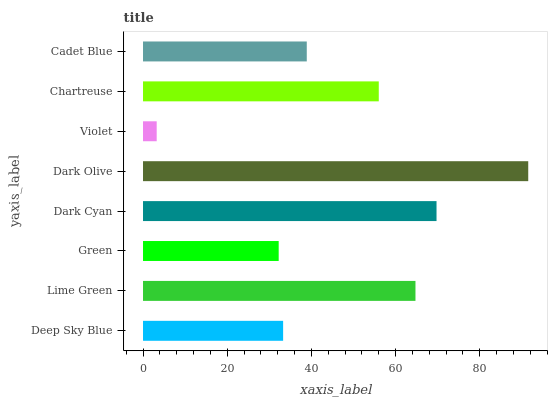Is Violet the minimum?
Answer yes or no. Yes. Is Dark Olive the maximum?
Answer yes or no. Yes. Is Lime Green the minimum?
Answer yes or no. No. Is Lime Green the maximum?
Answer yes or no. No. Is Lime Green greater than Deep Sky Blue?
Answer yes or no. Yes. Is Deep Sky Blue less than Lime Green?
Answer yes or no. Yes. Is Deep Sky Blue greater than Lime Green?
Answer yes or no. No. Is Lime Green less than Deep Sky Blue?
Answer yes or no. No. Is Chartreuse the high median?
Answer yes or no. Yes. Is Cadet Blue the low median?
Answer yes or no. Yes. Is Lime Green the high median?
Answer yes or no. No. Is Deep Sky Blue the low median?
Answer yes or no. No. 